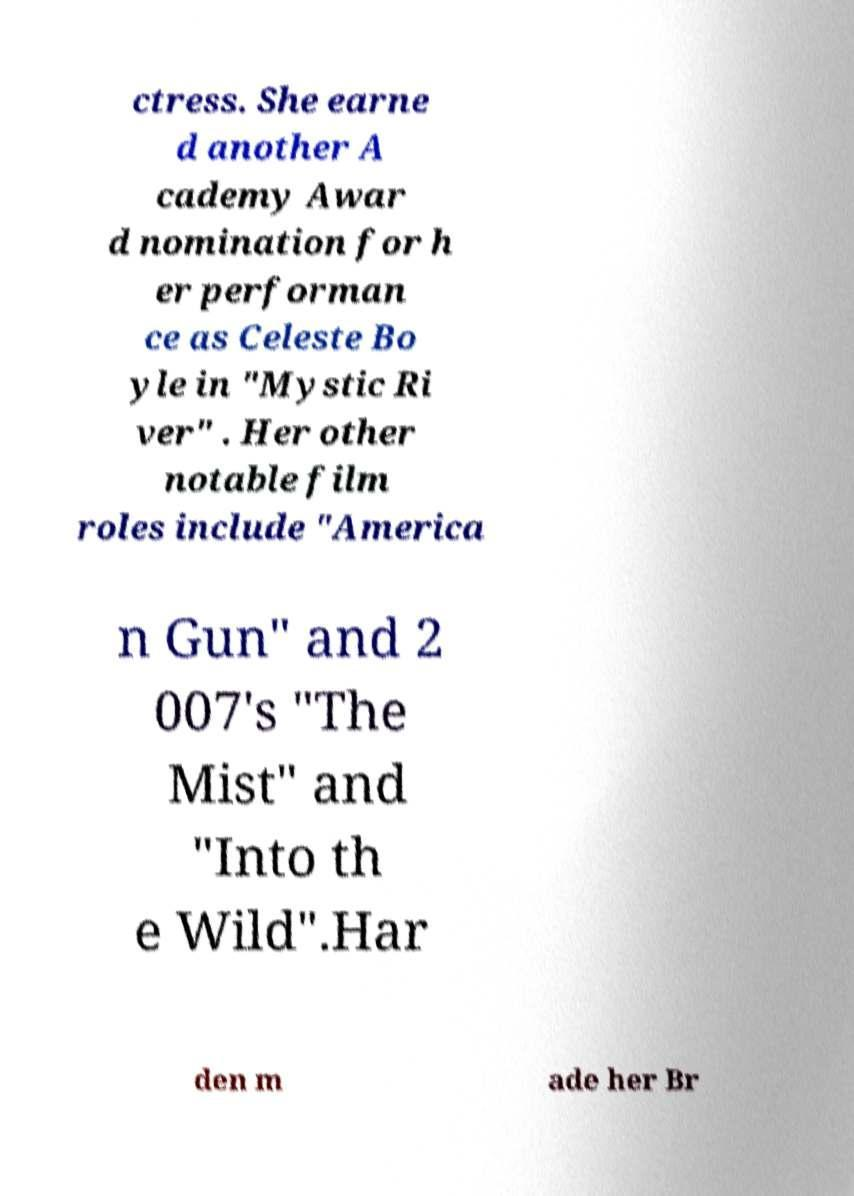Please read and relay the text visible in this image. What does it say? ctress. She earne d another A cademy Awar d nomination for h er performan ce as Celeste Bo yle in "Mystic Ri ver" . Her other notable film roles include "America n Gun" and 2 007's "The Mist" and "Into th e Wild".Har den m ade her Br 